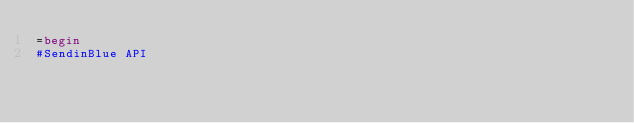Convert code to text. <code><loc_0><loc_0><loc_500><loc_500><_Ruby_>=begin
#SendinBlue API
</code> 